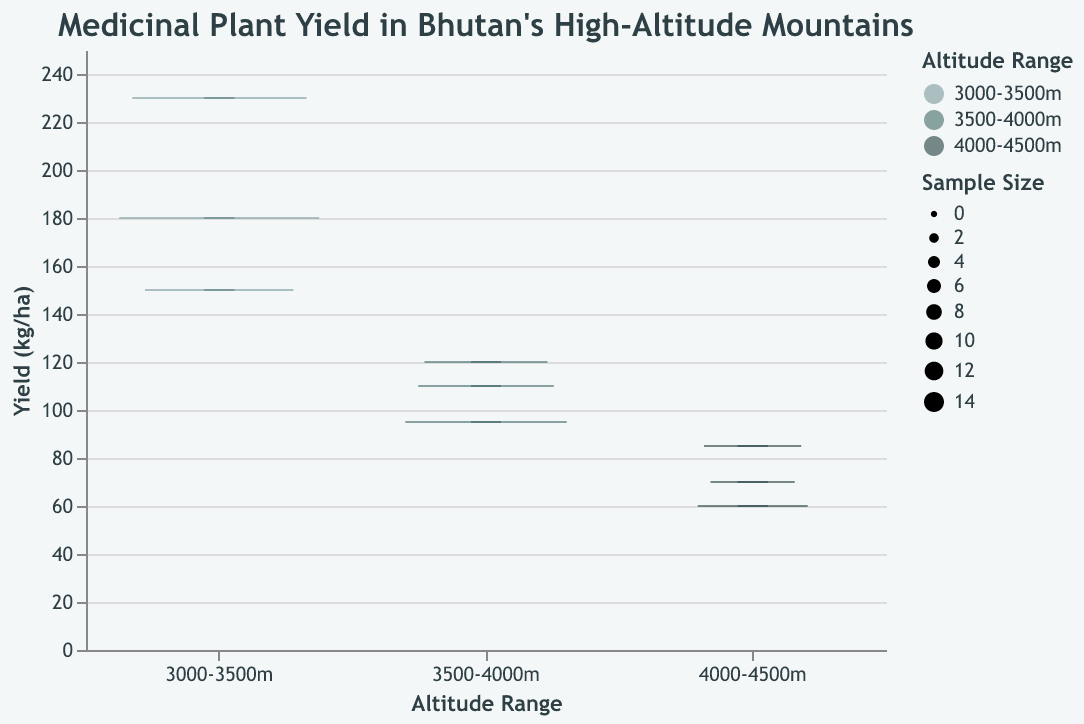What is the title of the figure? The title is located at the top of the figure and usually gives a summary of what the plot represents. The title states, "Medicinal Plant Yield in Bhutan's High-Altitude Mountains."
Answer: "Medicinal Plant Yield in Bhutan's High-Altitude Mountains" Which altitude range has the highest median yield? Identify which altitude range box has the highest median line. The 3000-3500m range has the highest median yield.
Answer: 3000-3500m What is the yield (kg/ha) for Nardostachys jatamansi? Identify the yield value for the plant "Nardostachys jatamansi" from the data. The yield (kg/ha) for Nardostachys jatamansi is 230 kg/ha.
Answer: 230 kg/ha How many samples are there for Saussurea obvallata? Find the sample size for the plant "Saussurea obvallata" from the data. The sample size for Saussurea obvallata is 6.
Answer: 6 Which altitude range has the smallest variability in yield? Assess the length of the box in each altitude range, where the shortest box indicates the smallest variability. The 4000-4500m altitude range has the smallest variability.
Answer: 4000-4500m Which medicinal plant has the lowest yield and what is its yield? Identify the plant with the lowest yield from the data. Artemisia maritima has the lowest yield at 60 kg/ha.
Answer: Artemisia maritima, 60 kg/ha Compare the median yield of plants in the 3500-4000m range with the 4000-4500m range. Which is higher? Locate the median lines for each range and compare their values. The median in the 3500-4000m range is higher than that in the 4000-4500m range.
Answer: 3500-4000m What is the sample size for the plant with the highest yield? Identify the plant with the highest yield and find the associated sample size from the data. Nardostachys jatamansi has the highest yield with a sample size of 12.
Answer: 12 Which altitude range has the most representative sample sizes? Examine the width of the boxes in each range, where wider boxes indicate more representative sample sizes. The 3000-3500m altitude range has the most representative sample sizes.
Answer: 3000-3500m Among plants found between 3500-4000m, which one has the lowest yield? Identify the lowest yield value within the 3500-4000m range. Bergenia ciliata has the lowest yield in this range at 95 kg/ha.
Answer: Bergenia ciliata 